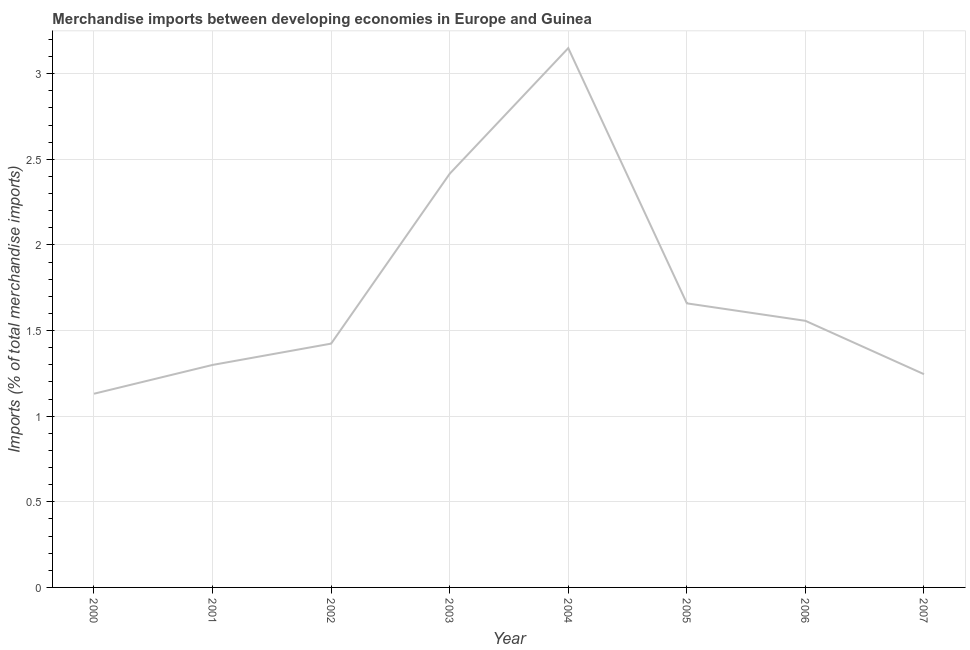What is the merchandise imports in 2002?
Provide a succinct answer. 1.42. Across all years, what is the maximum merchandise imports?
Your response must be concise. 3.15. Across all years, what is the minimum merchandise imports?
Provide a succinct answer. 1.13. In which year was the merchandise imports maximum?
Make the answer very short. 2004. What is the sum of the merchandise imports?
Make the answer very short. 13.88. What is the difference between the merchandise imports in 2001 and 2002?
Provide a succinct answer. -0.12. What is the average merchandise imports per year?
Keep it short and to the point. 1.74. What is the median merchandise imports?
Offer a very short reply. 1.49. What is the ratio of the merchandise imports in 2000 to that in 2004?
Give a very brief answer. 0.36. Is the difference between the merchandise imports in 2004 and 2007 greater than the difference between any two years?
Make the answer very short. No. What is the difference between the highest and the second highest merchandise imports?
Your answer should be compact. 0.73. What is the difference between the highest and the lowest merchandise imports?
Your answer should be very brief. 2.02. Does the merchandise imports monotonically increase over the years?
Your answer should be very brief. No. How many lines are there?
Your answer should be very brief. 1. How many years are there in the graph?
Your answer should be compact. 8. What is the difference between two consecutive major ticks on the Y-axis?
Provide a succinct answer. 0.5. Does the graph contain grids?
Your response must be concise. Yes. What is the title of the graph?
Provide a succinct answer. Merchandise imports between developing economies in Europe and Guinea. What is the label or title of the X-axis?
Provide a succinct answer. Year. What is the label or title of the Y-axis?
Ensure brevity in your answer.  Imports (% of total merchandise imports). What is the Imports (% of total merchandise imports) of 2000?
Your answer should be compact. 1.13. What is the Imports (% of total merchandise imports) of 2001?
Offer a very short reply. 1.3. What is the Imports (% of total merchandise imports) in 2002?
Keep it short and to the point. 1.42. What is the Imports (% of total merchandise imports) of 2003?
Offer a very short reply. 2.42. What is the Imports (% of total merchandise imports) in 2004?
Offer a very short reply. 3.15. What is the Imports (% of total merchandise imports) of 2005?
Provide a succinct answer. 1.66. What is the Imports (% of total merchandise imports) of 2006?
Your answer should be very brief. 1.56. What is the Imports (% of total merchandise imports) of 2007?
Provide a short and direct response. 1.25. What is the difference between the Imports (% of total merchandise imports) in 2000 and 2001?
Offer a terse response. -0.17. What is the difference between the Imports (% of total merchandise imports) in 2000 and 2002?
Your answer should be compact. -0.29. What is the difference between the Imports (% of total merchandise imports) in 2000 and 2003?
Offer a terse response. -1.28. What is the difference between the Imports (% of total merchandise imports) in 2000 and 2004?
Keep it short and to the point. -2.02. What is the difference between the Imports (% of total merchandise imports) in 2000 and 2005?
Ensure brevity in your answer.  -0.53. What is the difference between the Imports (% of total merchandise imports) in 2000 and 2006?
Offer a terse response. -0.43. What is the difference between the Imports (% of total merchandise imports) in 2000 and 2007?
Provide a succinct answer. -0.11. What is the difference between the Imports (% of total merchandise imports) in 2001 and 2002?
Your response must be concise. -0.12. What is the difference between the Imports (% of total merchandise imports) in 2001 and 2003?
Give a very brief answer. -1.12. What is the difference between the Imports (% of total merchandise imports) in 2001 and 2004?
Offer a terse response. -1.85. What is the difference between the Imports (% of total merchandise imports) in 2001 and 2005?
Give a very brief answer. -0.36. What is the difference between the Imports (% of total merchandise imports) in 2001 and 2006?
Provide a short and direct response. -0.26. What is the difference between the Imports (% of total merchandise imports) in 2001 and 2007?
Your response must be concise. 0.05. What is the difference between the Imports (% of total merchandise imports) in 2002 and 2003?
Offer a very short reply. -0.99. What is the difference between the Imports (% of total merchandise imports) in 2002 and 2004?
Keep it short and to the point. -1.73. What is the difference between the Imports (% of total merchandise imports) in 2002 and 2005?
Offer a very short reply. -0.24. What is the difference between the Imports (% of total merchandise imports) in 2002 and 2006?
Keep it short and to the point. -0.13. What is the difference between the Imports (% of total merchandise imports) in 2002 and 2007?
Your answer should be compact. 0.18. What is the difference between the Imports (% of total merchandise imports) in 2003 and 2004?
Make the answer very short. -0.73. What is the difference between the Imports (% of total merchandise imports) in 2003 and 2005?
Offer a very short reply. 0.76. What is the difference between the Imports (% of total merchandise imports) in 2003 and 2006?
Make the answer very short. 0.86. What is the difference between the Imports (% of total merchandise imports) in 2003 and 2007?
Offer a very short reply. 1.17. What is the difference between the Imports (% of total merchandise imports) in 2004 and 2005?
Your response must be concise. 1.49. What is the difference between the Imports (% of total merchandise imports) in 2004 and 2006?
Your answer should be very brief. 1.59. What is the difference between the Imports (% of total merchandise imports) in 2004 and 2007?
Make the answer very short. 1.9. What is the difference between the Imports (% of total merchandise imports) in 2005 and 2006?
Provide a short and direct response. 0.1. What is the difference between the Imports (% of total merchandise imports) in 2005 and 2007?
Your response must be concise. 0.41. What is the difference between the Imports (% of total merchandise imports) in 2006 and 2007?
Ensure brevity in your answer.  0.31. What is the ratio of the Imports (% of total merchandise imports) in 2000 to that in 2001?
Your response must be concise. 0.87. What is the ratio of the Imports (% of total merchandise imports) in 2000 to that in 2002?
Offer a very short reply. 0.79. What is the ratio of the Imports (% of total merchandise imports) in 2000 to that in 2003?
Give a very brief answer. 0.47. What is the ratio of the Imports (% of total merchandise imports) in 2000 to that in 2004?
Give a very brief answer. 0.36. What is the ratio of the Imports (% of total merchandise imports) in 2000 to that in 2005?
Provide a succinct answer. 0.68. What is the ratio of the Imports (% of total merchandise imports) in 2000 to that in 2006?
Keep it short and to the point. 0.73. What is the ratio of the Imports (% of total merchandise imports) in 2000 to that in 2007?
Your answer should be compact. 0.91. What is the ratio of the Imports (% of total merchandise imports) in 2001 to that in 2003?
Keep it short and to the point. 0.54. What is the ratio of the Imports (% of total merchandise imports) in 2001 to that in 2004?
Offer a very short reply. 0.41. What is the ratio of the Imports (% of total merchandise imports) in 2001 to that in 2005?
Make the answer very short. 0.78. What is the ratio of the Imports (% of total merchandise imports) in 2001 to that in 2006?
Your response must be concise. 0.83. What is the ratio of the Imports (% of total merchandise imports) in 2001 to that in 2007?
Your answer should be compact. 1.04. What is the ratio of the Imports (% of total merchandise imports) in 2002 to that in 2003?
Offer a very short reply. 0.59. What is the ratio of the Imports (% of total merchandise imports) in 2002 to that in 2004?
Keep it short and to the point. 0.45. What is the ratio of the Imports (% of total merchandise imports) in 2002 to that in 2005?
Give a very brief answer. 0.86. What is the ratio of the Imports (% of total merchandise imports) in 2002 to that in 2006?
Give a very brief answer. 0.91. What is the ratio of the Imports (% of total merchandise imports) in 2002 to that in 2007?
Offer a terse response. 1.14. What is the ratio of the Imports (% of total merchandise imports) in 2003 to that in 2004?
Make the answer very short. 0.77. What is the ratio of the Imports (% of total merchandise imports) in 2003 to that in 2005?
Provide a short and direct response. 1.46. What is the ratio of the Imports (% of total merchandise imports) in 2003 to that in 2006?
Your answer should be very brief. 1.55. What is the ratio of the Imports (% of total merchandise imports) in 2003 to that in 2007?
Keep it short and to the point. 1.94. What is the ratio of the Imports (% of total merchandise imports) in 2004 to that in 2005?
Keep it short and to the point. 1.9. What is the ratio of the Imports (% of total merchandise imports) in 2004 to that in 2006?
Provide a short and direct response. 2.02. What is the ratio of the Imports (% of total merchandise imports) in 2004 to that in 2007?
Provide a short and direct response. 2.53. What is the ratio of the Imports (% of total merchandise imports) in 2005 to that in 2006?
Ensure brevity in your answer.  1.07. What is the ratio of the Imports (% of total merchandise imports) in 2005 to that in 2007?
Provide a short and direct response. 1.33. 